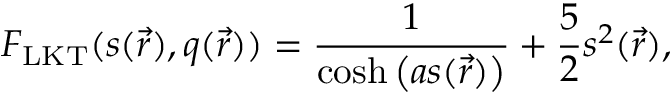<formula> <loc_0><loc_0><loc_500><loc_500>F _ { L K T } ( s ( \vec { r } ) , q ( \vec { r } ) ) = \frac { 1 } { \cosh \left ( a s ( \vec { r } ) \right ) } + \frac { 5 } { 2 } s ^ { 2 } ( \vec { r } ) ,</formula> 